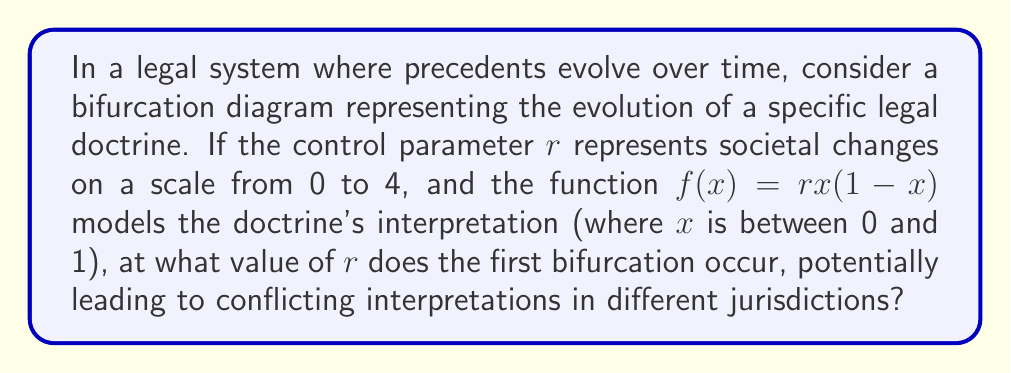Can you solve this math problem? To solve this problem, we need to understand the logistic map and its bifurcation properties:

1. The logistic map is given by the function $f(x) = rx(1-x)$, where $r$ is the control parameter.

2. As $r$ increases, the behavior of the system changes, leading to bifurcations.

3. The first bifurcation occurs when the fixed point becomes unstable and splits into two periodic points.

4. To find this point, we need to solve the equation:
   
   $$f'(x^*) = -1$$

   where $x^*$ is the non-zero fixed point of the map.

5. The fixed point $x^*$ is given by:
   
   $$x^* = 1 - \frac{1}{r}$$

6. Now, let's calculate $f'(x)$:
   
   $$f'(x) = r(1-2x)$$

7. Substituting $x^*$ into $f'(x)$ and setting it equal to -1:
   
   $$r(1-2(1-\frac{1}{r})) = -1$$

8. Simplifying:
   
   $$r(1-2+\frac{2}{r}) = -1$$
   $$r(-1+\frac{2}{r}) = -1$$
   $$-r+2 = -1$$
   $$r = 3$$

Therefore, the first bifurcation occurs when $r = 3$.
Answer: $r = 3$ 